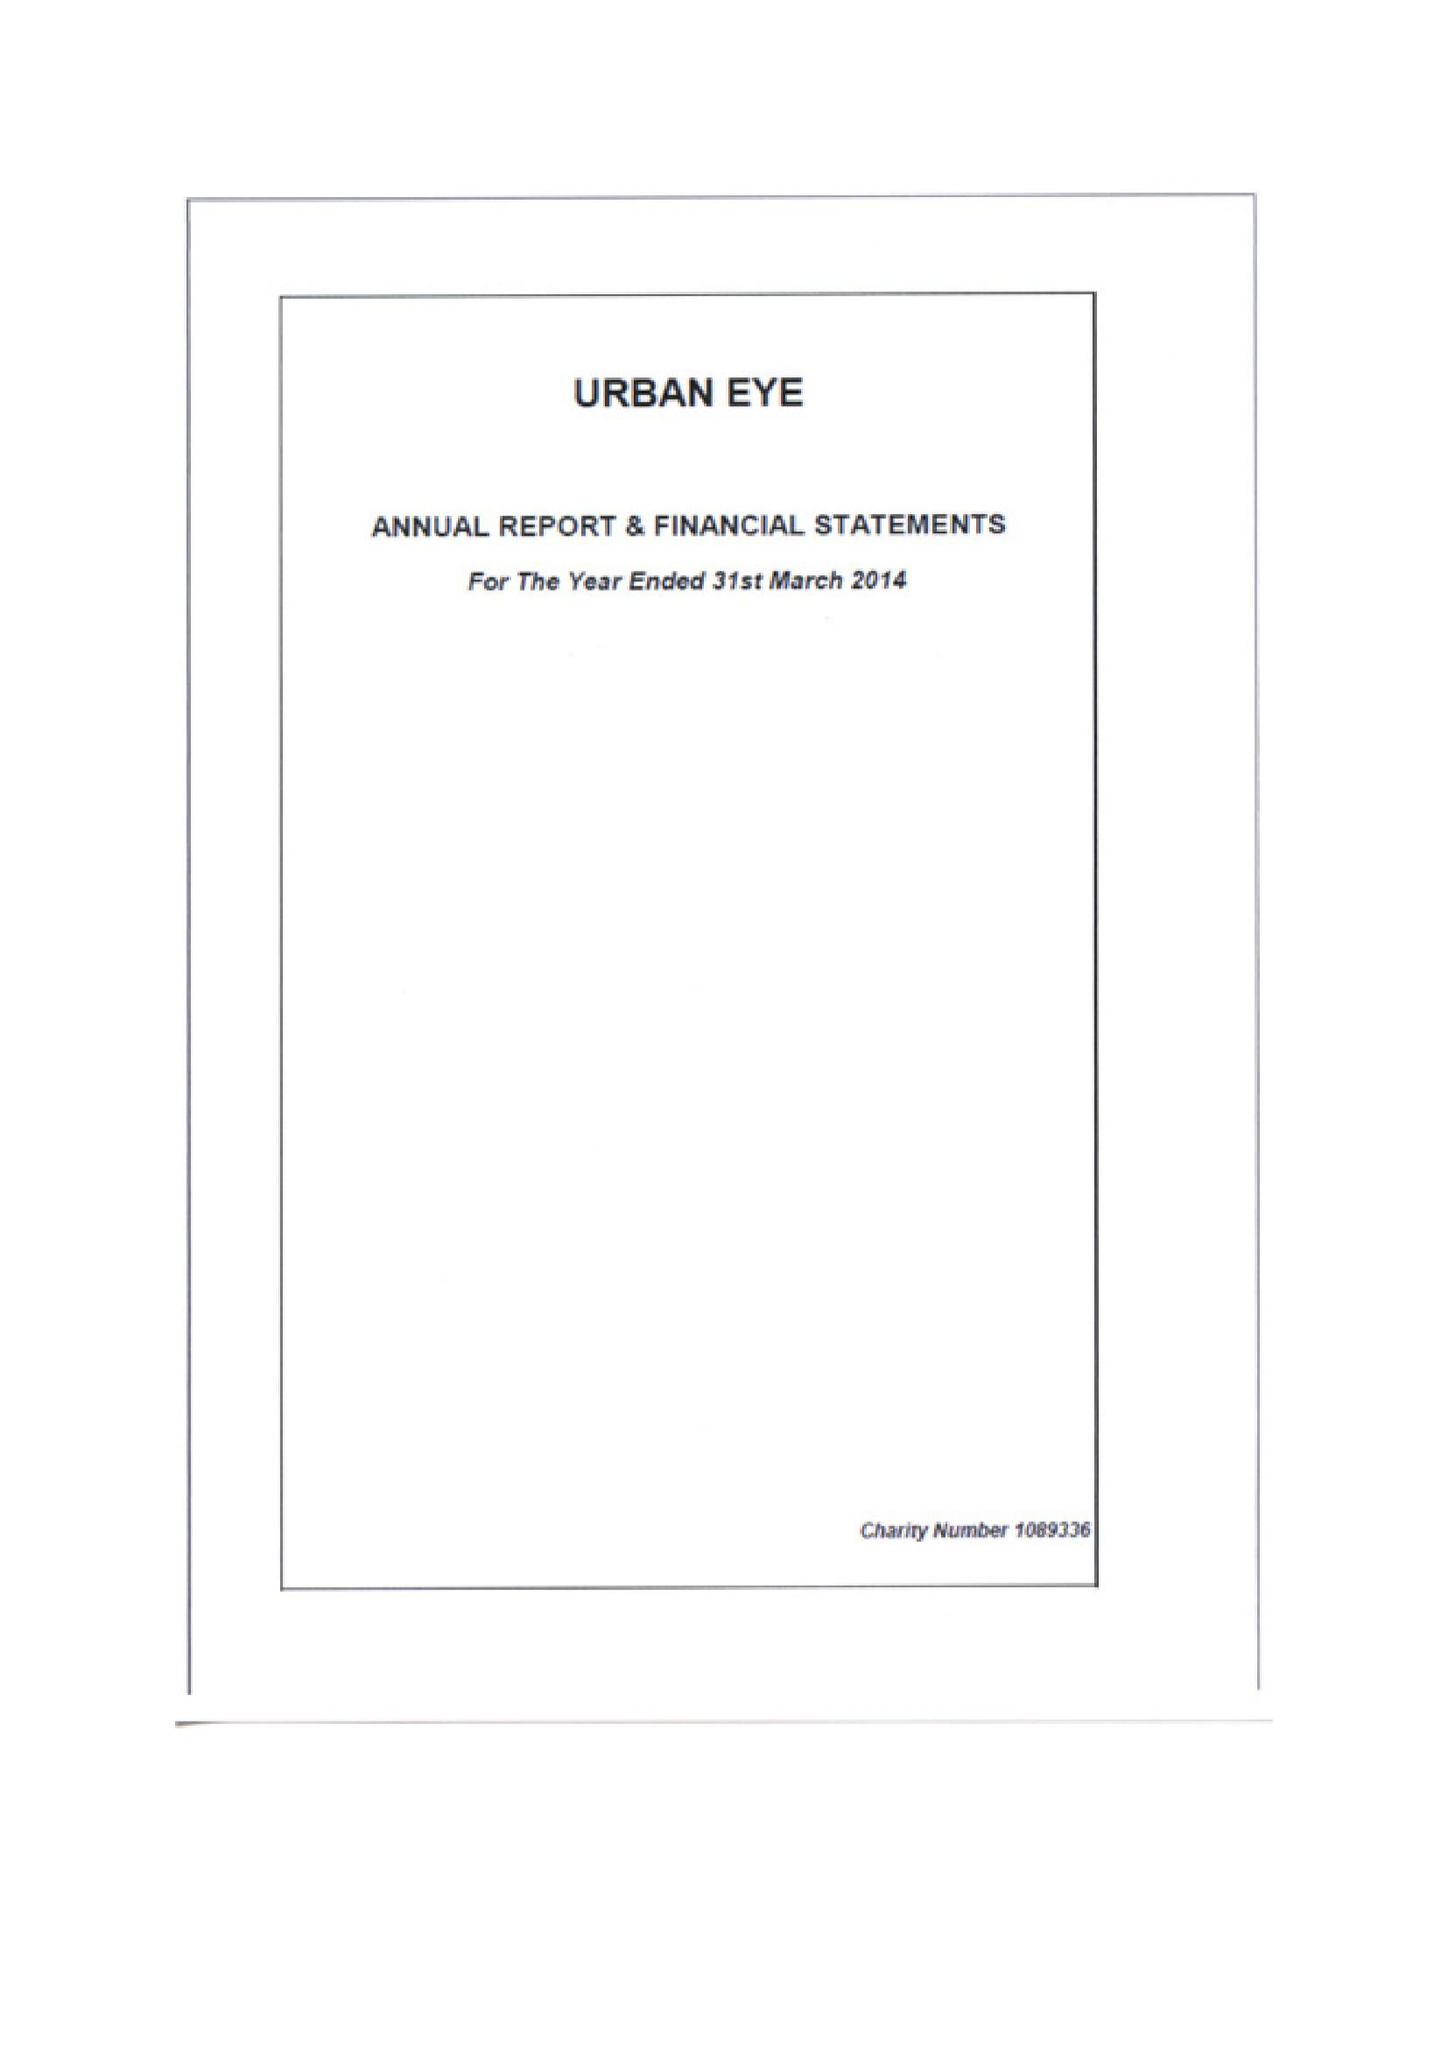What is the value for the address__postcode?
Answer the question using a single word or phrase. W11 4AT 